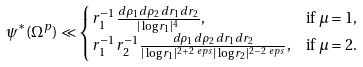<formula> <loc_0><loc_0><loc_500><loc_500>\psi ^ { * } ( \Omega ^ { p } ) & \ll \begin{cases} r _ { 1 } ^ { - 1 } \frac { d \rho _ { 1 } d \rho _ { 2 } \, d r _ { 1 } d r _ { 2 } } { | \log r _ { 1 } | ^ { 4 } } , & \text {if $\mu=1$,} \\ r _ { 1 } ^ { - 1 } r _ { 2 } ^ { - 1 } \frac { d \rho _ { 1 } d \rho _ { 2 } \, d r _ { 1 } d r _ { 2 } } { | \log r _ { 1 } | ^ { 2 + 2 \ e p s } | \log r _ { 2 } | ^ { 2 - 2 \ e p s } } , & \text {if $\mu=2$.} \end{cases}</formula> 